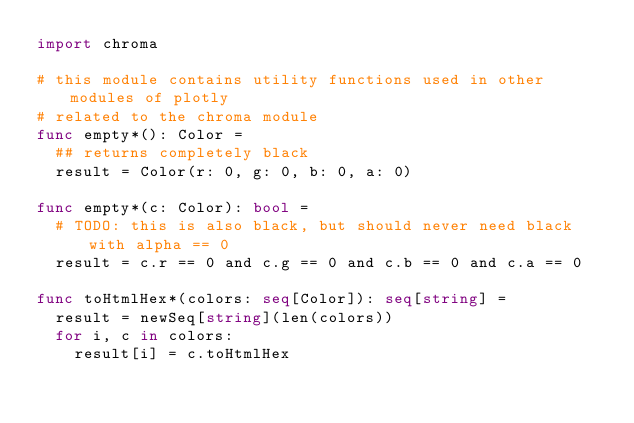Convert code to text. <code><loc_0><loc_0><loc_500><loc_500><_Nim_>import chroma

# this module contains utility functions used in other modules of plotly
# related to the chroma module
func empty*(): Color =
  ## returns completely black
  result = Color(r: 0, g: 0, b: 0, a: 0)

func empty*(c: Color): bool =
  # TODO: this is also black, but should never need black with alpha == 0
  result = c.r == 0 and c.g == 0 and c.b == 0 and c.a == 0

func toHtmlHex*(colors: seq[Color]): seq[string] =
  result = newSeq[string](len(colors))
  for i, c in colors:
    result[i] = c.toHtmlHex
</code> 